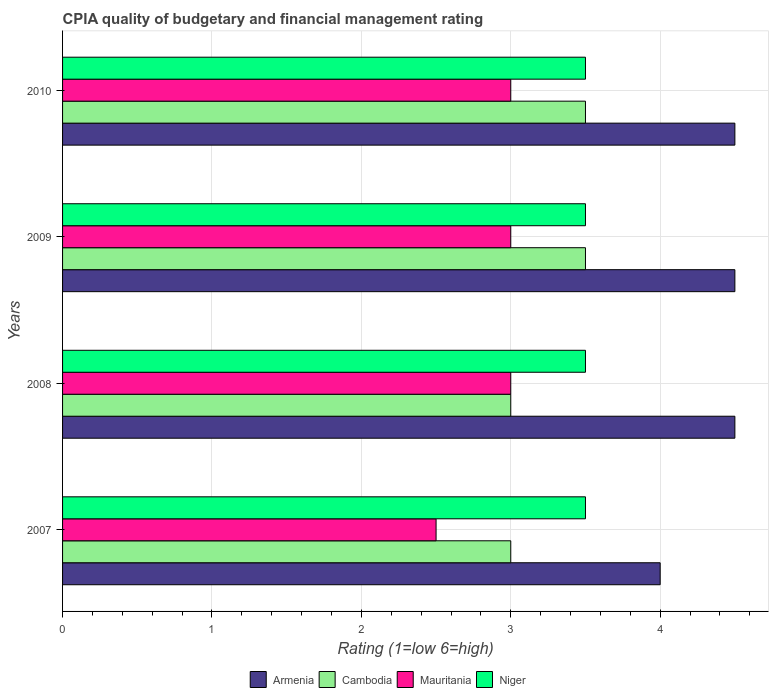How many groups of bars are there?
Your answer should be very brief. 4. Are the number of bars per tick equal to the number of legend labels?
Your answer should be very brief. Yes. What is the label of the 4th group of bars from the top?
Ensure brevity in your answer.  2007. Across all years, what is the maximum CPIA rating in Cambodia?
Your response must be concise. 3.5. Across all years, what is the minimum CPIA rating in Cambodia?
Ensure brevity in your answer.  3. In which year was the CPIA rating in Armenia minimum?
Offer a terse response. 2007. What is the total CPIA rating in Cambodia in the graph?
Provide a succinct answer. 13. What is the difference between the CPIA rating in Cambodia in 2007 and that in 2010?
Provide a short and direct response. -0.5. What is the average CPIA rating in Armenia per year?
Provide a succinct answer. 4.38. In the year 2009, what is the difference between the CPIA rating in Armenia and CPIA rating in Niger?
Keep it short and to the point. 1. In how many years, is the CPIA rating in Armenia greater than 0.6000000000000001 ?
Keep it short and to the point. 4. What is the difference between the highest and the lowest CPIA rating in Armenia?
Provide a succinct answer. 0.5. Is it the case that in every year, the sum of the CPIA rating in Cambodia and CPIA rating in Mauritania is greater than the sum of CPIA rating in Armenia and CPIA rating in Niger?
Provide a short and direct response. No. What does the 3rd bar from the top in 2008 represents?
Offer a very short reply. Cambodia. What does the 2nd bar from the bottom in 2008 represents?
Give a very brief answer. Cambodia. Is it the case that in every year, the sum of the CPIA rating in Armenia and CPIA rating in Cambodia is greater than the CPIA rating in Niger?
Ensure brevity in your answer.  Yes. How many bars are there?
Your answer should be compact. 16. How many years are there in the graph?
Your answer should be very brief. 4. What is the difference between two consecutive major ticks on the X-axis?
Provide a succinct answer. 1. Are the values on the major ticks of X-axis written in scientific E-notation?
Give a very brief answer. No. Does the graph contain any zero values?
Ensure brevity in your answer.  No. Where does the legend appear in the graph?
Offer a terse response. Bottom center. How many legend labels are there?
Ensure brevity in your answer.  4. How are the legend labels stacked?
Keep it short and to the point. Horizontal. What is the title of the graph?
Your answer should be very brief. CPIA quality of budgetary and financial management rating. Does "Kyrgyz Republic" appear as one of the legend labels in the graph?
Keep it short and to the point. No. What is the label or title of the X-axis?
Offer a terse response. Rating (1=low 6=high). What is the label or title of the Y-axis?
Your response must be concise. Years. What is the Rating (1=low 6=high) of Armenia in 2007?
Your response must be concise. 4. What is the Rating (1=low 6=high) of Mauritania in 2007?
Your answer should be very brief. 2.5. What is the Rating (1=low 6=high) of Niger in 2007?
Provide a succinct answer. 3.5. What is the Rating (1=low 6=high) of Cambodia in 2008?
Give a very brief answer. 3. What is the Rating (1=low 6=high) in Niger in 2008?
Ensure brevity in your answer.  3.5. What is the Rating (1=low 6=high) in Cambodia in 2009?
Your response must be concise. 3.5. What is the Rating (1=low 6=high) in Armenia in 2010?
Your answer should be very brief. 4.5. What is the Rating (1=low 6=high) of Cambodia in 2010?
Your response must be concise. 3.5. What is the Rating (1=low 6=high) of Mauritania in 2010?
Give a very brief answer. 3. Across all years, what is the maximum Rating (1=low 6=high) of Armenia?
Provide a short and direct response. 4.5. Across all years, what is the maximum Rating (1=low 6=high) in Cambodia?
Provide a short and direct response. 3.5. Across all years, what is the maximum Rating (1=low 6=high) of Mauritania?
Provide a succinct answer. 3. Across all years, what is the minimum Rating (1=low 6=high) in Niger?
Keep it short and to the point. 3.5. What is the total Rating (1=low 6=high) in Niger in the graph?
Make the answer very short. 14. What is the difference between the Rating (1=low 6=high) in Niger in 2007 and that in 2008?
Provide a short and direct response. 0. What is the difference between the Rating (1=low 6=high) of Mauritania in 2007 and that in 2009?
Provide a short and direct response. -0.5. What is the difference between the Rating (1=low 6=high) in Niger in 2007 and that in 2009?
Offer a terse response. 0. What is the difference between the Rating (1=low 6=high) of Armenia in 2007 and that in 2010?
Provide a short and direct response. -0.5. What is the difference between the Rating (1=low 6=high) of Cambodia in 2007 and that in 2010?
Make the answer very short. -0.5. What is the difference between the Rating (1=low 6=high) in Mauritania in 2007 and that in 2010?
Ensure brevity in your answer.  -0.5. What is the difference between the Rating (1=low 6=high) in Mauritania in 2008 and that in 2009?
Provide a succinct answer. 0. What is the difference between the Rating (1=low 6=high) of Niger in 2008 and that in 2009?
Offer a very short reply. 0. What is the difference between the Rating (1=low 6=high) in Mauritania in 2008 and that in 2010?
Your answer should be very brief. 0. What is the difference between the Rating (1=low 6=high) of Niger in 2009 and that in 2010?
Give a very brief answer. 0. What is the difference between the Rating (1=low 6=high) in Armenia in 2007 and the Rating (1=low 6=high) in Mauritania in 2008?
Keep it short and to the point. 1. What is the difference between the Rating (1=low 6=high) in Cambodia in 2007 and the Rating (1=low 6=high) in Mauritania in 2008?
Ensure brevity in your answer.  0. What is the difference between the Rating (1=low 6=high) of Armenia in 2007 and the Rating (1=low 6=high) of Cambodia in 2009?
Provide a succinct answer. 0.5. What is the difference between the Rating (1=low 6=high) in Cambodia in 2007 and the Rating (1=low 6=high) in Niger in 2009?
Provide a succinct answer. -0.5. What is the difference between the Rating (1=low 6=high) of Mauritania in 2007 and the Rating (1=low 6=high) of Niger in 2009?
Keep it short and to the point. -1. What is the difference between the Rating (1=low 6=high) of Armenia in 2007 and the Rating (1=low 6=high) of Cambodia in 2010?
Your answer should be compact. 0.5. What is the difference between the Rating (1=low 6=high) of Armenia in 2007 and the Rating (1=low 6=high) of Mauritania in 2010?
Ensure brevity in your answer.  1. What is the difference between the Rating (1=low 6=high) of Armenia in 2007 and the Rating (1=low 6=high) of Niger in 2010?
Provide a succinct answer. 0.5. What is the difference between the Rating (1=low 6=high) of Mauritania in 2007 and the Rating (1=low 6=high) of Niger in 2010?
Ensure brevity in your answer.  -1. What is the difference between the Rating (1=low 6=high) of Armenia in 2008 and the Rating (1=low 6=high) of Mauritania in 2009?
Provide a succinct answer. 1.5. What is the difference between the Rating (1=low 6=high) in Armenia in 2008 and the Rating (1=low 6=high) in Niger in 2009?
Give a very brief answer. 1. What is the difference between the Rating (1=low 6=high) in Cambodia in 2008 and the Rating (1=low 6=high) in Niger in 2009?
Your response must be concise. -0.5. What is the difference between the Rating (1=low 6=high) in Armenia in 2008 and the Rating (1=low 6=high) in Cambodia in 2010?
Provide a short and direct response. 1. What is the difference between the Rating (1=low 6=high) in Armenia in 2008 and the Rating (1=low 6=high) in Mauritania in 2010?
Provide a short and direct response. 1.5. What is the difference between the Rating (1=low 6=high) in Armenia in 2008 and the Rating (1=low 6=high) in Niger in 2010?
Your answer should be very brief. 1. What is the difference between the Rating (1=low 6=high) of Cambodia in 2008 and the Rating (1=low 6=high) of Mauritania in 2010?
Keep it short and to the point. 0. What is the difference between the Rating (1=low 6=high) of Cambodia in 2008 and the Rating (1=low 6=high) of Niger in 2010?
Offer a very short reply. -0.5. What is the difference between the Rating (1=low 6=high) of Armenia in 2009 and the Rating (1=low 6=high) of Cambodia in 2010?
Your response must be concise. 1. What is the difference between the Rating (1=low 6=high) in Cambodia in 2009 and the Rating (1=low 6=high) in Mauritania in 2010?
Offer a terse response. 0.5. What is the difference between the Rating (1=low 6=high) in Mauritania in 2009 and the Rating (1=low 6=high) in Niger in 2010?
Offer a very short reply. -0.5. What is the average Rating (1=low 6=high) in Armenia per year?
Keep it short and to the point. 4.38. What is the average Rating (1=low 6=high) of Cambodia per year?
Give a very brief answer. 3.25. What is the average Rating (1=low 6=high) of Mauritania per year?
Your answer should be very brief. 2.88. In the year 2008, what is the difference between the Rating (1=low 6=high) in Armenia and Rating (1=low 6=high) in Cambodia?
Provide a short and direct response. 1.5. In the year 2008, what is the difference between the Rating (1=low 6=high) of Armenia and Rating (1=low 6=high) of Mauritania?
Provide a succinct answer. 1.5. In the year 2008, what is the difference between the Rating (1=low 6=high) of Armenia and Rating (1=low 6=high) of Niger?
Give a very brief answer. 1. In the year 2008, what is the difference between the Rating (1=low 6=high) in Cambodia and Rating (1=low 6=high) in Mauritania?
Keep it short and to the point. 0. In the year 2009, what is the difference between the Rating (1=low 6=high) in Armenia and Rating (1=low 6=high) in Cambodia?
Keep it short and to the point. 1. In the year 2009, what is the difference between the Rating (1=low 6=high) in Armenia and Rating (1=low 6=high) in Mauritania?
Give a very brief answer. 1.5. In the year 2009, what is the difference between the Rating (1=low 6=high) in Cambodia and Rating (1=low 6=high) in Mauritania?
Provide a short and direct response. 0.5. In the year 2009, what is the difference between the Rating (1=low 6=high) in Cambodia and Rating (1=low 6=high) in Niger?
Your answer should be compact. 0. In the year 2009, what is the difference between the Rating (1=low 6=high) of Mauritania and Rating (1=low 6=high) of Niger?
Ensure brevity in your answer.  -0.5. In the year 2010, what is the difference between the Rating (1=low 6=high) of Armenia and Rating (1=low 6=high) of Mauritania?
Your answer should be very brief. 1.5. In the year 2010, what is the difference between the Rating (1=low 6=high) of Armenia and Rating (1=low 6=high) of Niger?
Your answer should be very brief. 1. In the year 2010, what is the difference between the Rating (1=low 6=high) of Cambodia and Rating (1=low 6=high) of Mauritania?
Keep it short and to the point. 0.5. In the year 2010, what is the difference between the Rating (1=low 6=high) of Mauritania and Rating (1=low 6=high) of Niger?
Keep it short and to the point. -0.5. What is the ratio of the Rating (1=low 6=high) of Armenia in 2007 to that in 2008?
Offer a terse response. 0.89. What is the ratio of the Rating (1=low 6=high) of Cambodia in 2007 to that in 2008?
Offer a terse response. 1. What is the ratio of the Rating (1=low 6=high) in Mauritania in 2007 to that in 2008?
Ensure brevity in your answer.  0.83. What is the ratio of the Rating (1=low 6=high) in Niger in 2007 to that in 2008?
Provide a succinct answer. 1. What is the ratio of the Rating (1=low 6=high) of Cambodia in 2007 to that in 2009?
Provide a short and direct response. 0.86. What is the ratio of the Rating (1=low 6=high) of Mauritania in 2007 to that in 2009?
Your response must be concise. 0.83. What is the ratio of the Rating (1=low 6=high) of Armenia in 2007 to that in 2010?
Your answer should be very brief. 0.89. What is the ratio of the Rating (1=low 6=high) in Cambodia in 2007 to that in 2010?
Your answer should be compact. 0.86. What is the ratio of the Rating (1=low 6=high) of Armenia in 2008 to that in 2009?
Ensure brevity in your answer.  1. What is the ratio of the Rating (1=low 6=high) in Mauritania in 2008 to that in 2009?
Offer a terse response. 1. What is the ratio of the Rating (1=low 6=high) in Niger in 2008 to that in 2009?
Provide a short and direct response. 1. What is the ratio of the Rating (1=low 6=high) of Cambodia in 2008 to that in 2010?
Keep it short and to the point. 0.86. What is the ratio of the Rating (1=low 6=high) in Niger in 2008 to that in 2010?
Your response must be concise. 1. What is the ratio of the Rating (1=low 6=high) in Niger in 2009 to that in 2010?
Make the answer very short. 1. What is the difference between the highest and the second highest Rating (1=low 6=high) of Cambodia?
Give a very brief answer. 0. What is the difference between the highest and the second highest Rating (1=low 6=high) in Mauritania?
Ensure brevity in your answer.  0. What is the difference between the highest and the lowest Rating (1=low 6=high) in Cambodia?
Your answer should be very brief. 0.5. 